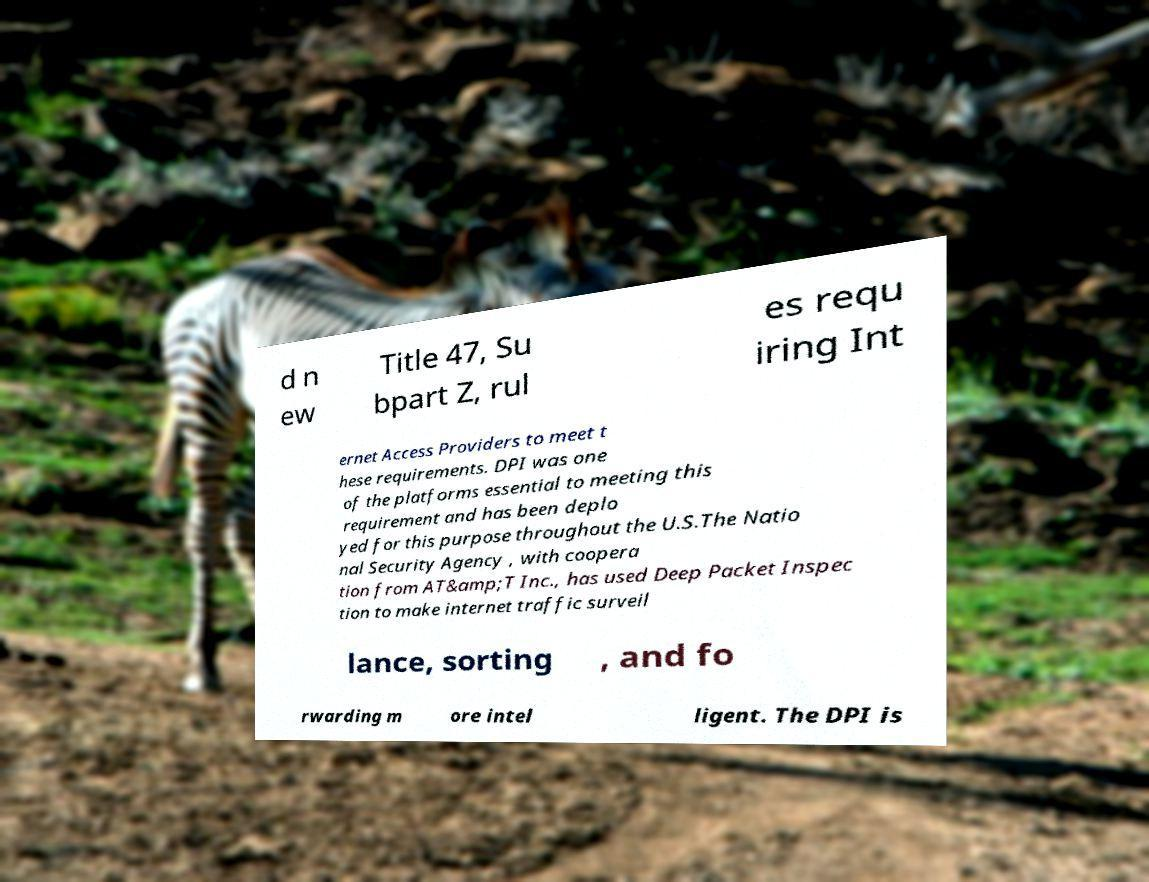Can you accurately transcribe the text from the provided image for me? d n ew Title 47, Su bpart Z, rul es requ iring Int ernet Access Providers to meet t hese requirements. DPI was one of the platforms essential to meeting this requirement and has been deplo yed for this purpose throughout the U.S.The Natio nal Security Agency , with coopera tion from AT&amp;T Inc., has used Deep Packet Inspec tion to make internet traffic surveil lance, sorting , and fo rwarding m ore intel ligent. The DPI is 